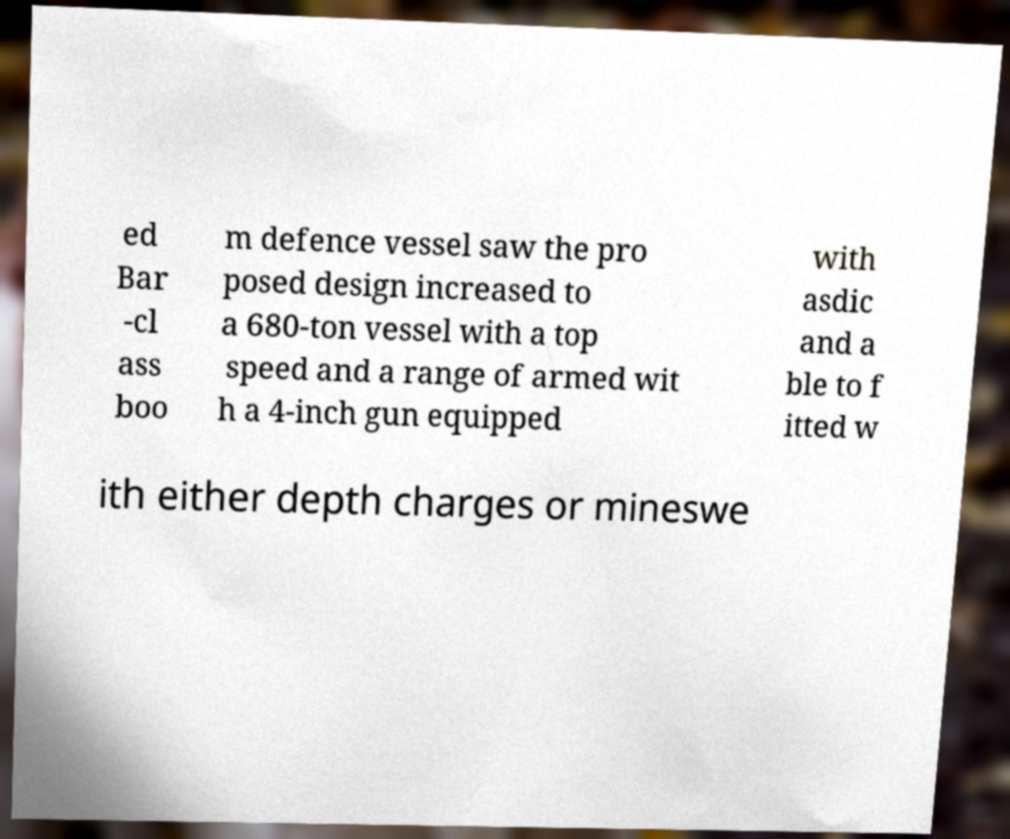There's text embedded in this image that I need extracted. Can you transcribe it verbatim? ed Bar -cl ass boo m defence vessel saw the pro posed design increased to a 680-ton vessel with a top speed and a range of armed wit h a 4-inch gun equipped with asdic and a ble to f itted w ith either depth charges or mineswe 